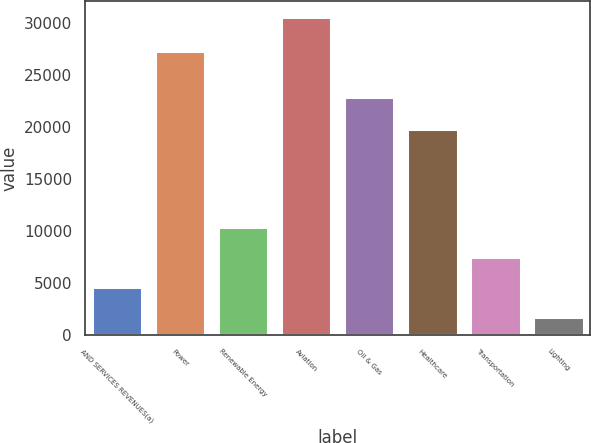<chart> <loc_0><loc_0><loc_500><loc_500><bar_chart><fcel>AND SERVICES REVENUES(a)<fcel>Power<fcel>Renewable Energy<fcel>Aviation<fcel>Oil & Gas<fcel>Healthcare<fcel>Transportation<fcel>Lighting<nl><fcel>4607.3<fcel>27300<fcel>10375.9<fcel>30566<fcel>22859<fcel>19784<fcel>7491.6<fcel>1723<nl></chart> 